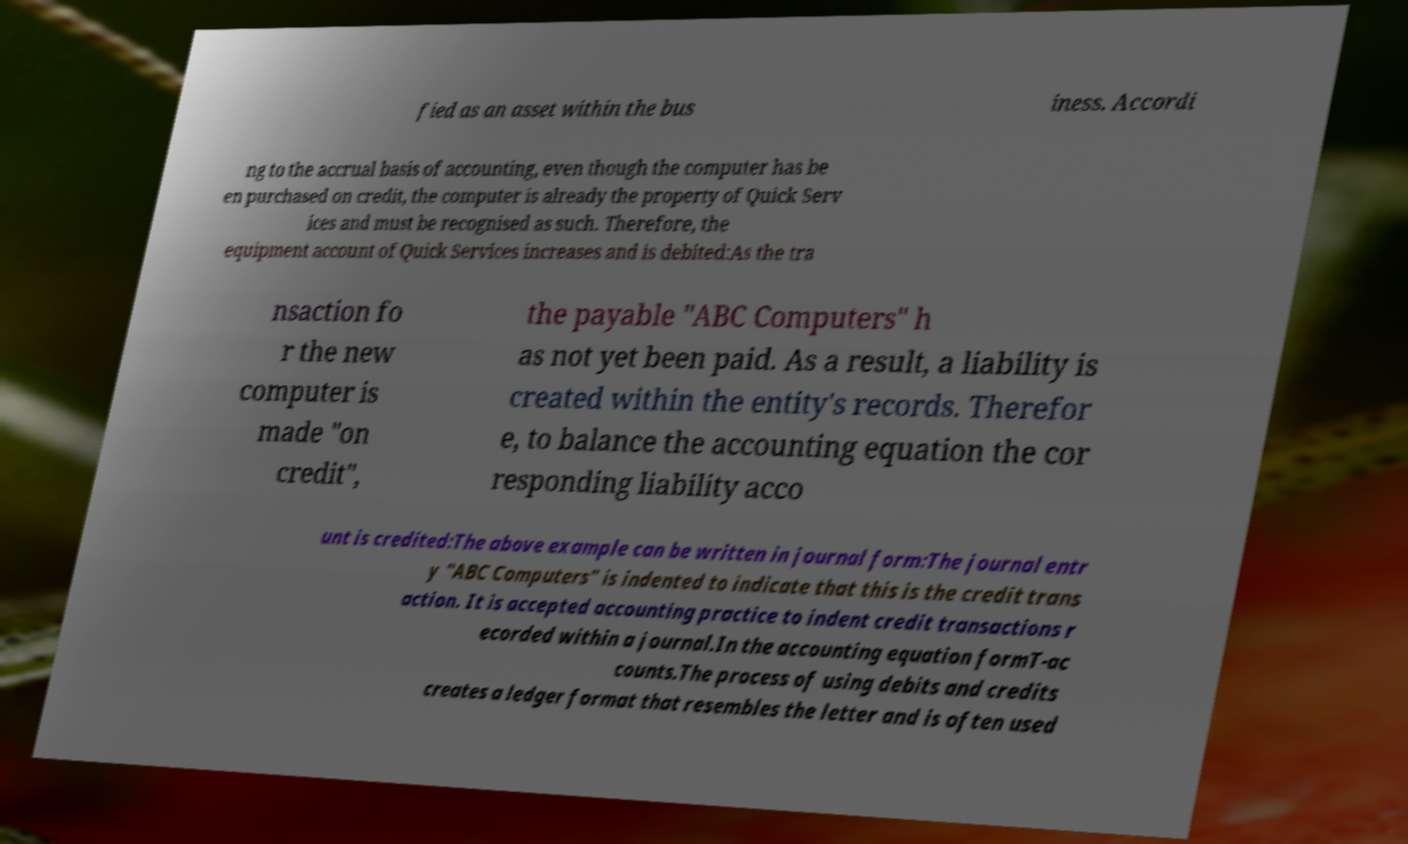Please identify and transcribe the text found in this image. fied as an asset within the bus iness. Accordi ng to the accrual basis of accounting, even though the computer has be en purchased on credit, the computer is already the property of Quick Serv ices and must be recognised as such. Therefore, the equipment account of Quick Services increases and is debited:As the tra nsaction fo r the new computer is made "on credit", the payable "ABC Computers" h as not yet been paid. As a result, a liability is created within the entity's records. Therefor e, to balance the accounting equation the cor responding liability acco unt is credited:The above example can be written in journal form:The journal entr y "ABC Computers" is indented to indicate that this is the credit trans action. It is accepted accounting practice to indent credit transactions r ecorded within a journal.In the accounting equation formT-ac counts.The process of using debits and credits creates a ledger format that resembles the letter and is often used 